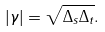Convert formula to latex. <formula><loc_0><loc_0><loc_500><loc_500>| \gamma | = \sqrt { \Delta _ { s } \Delta _ { t } } .</formula> 